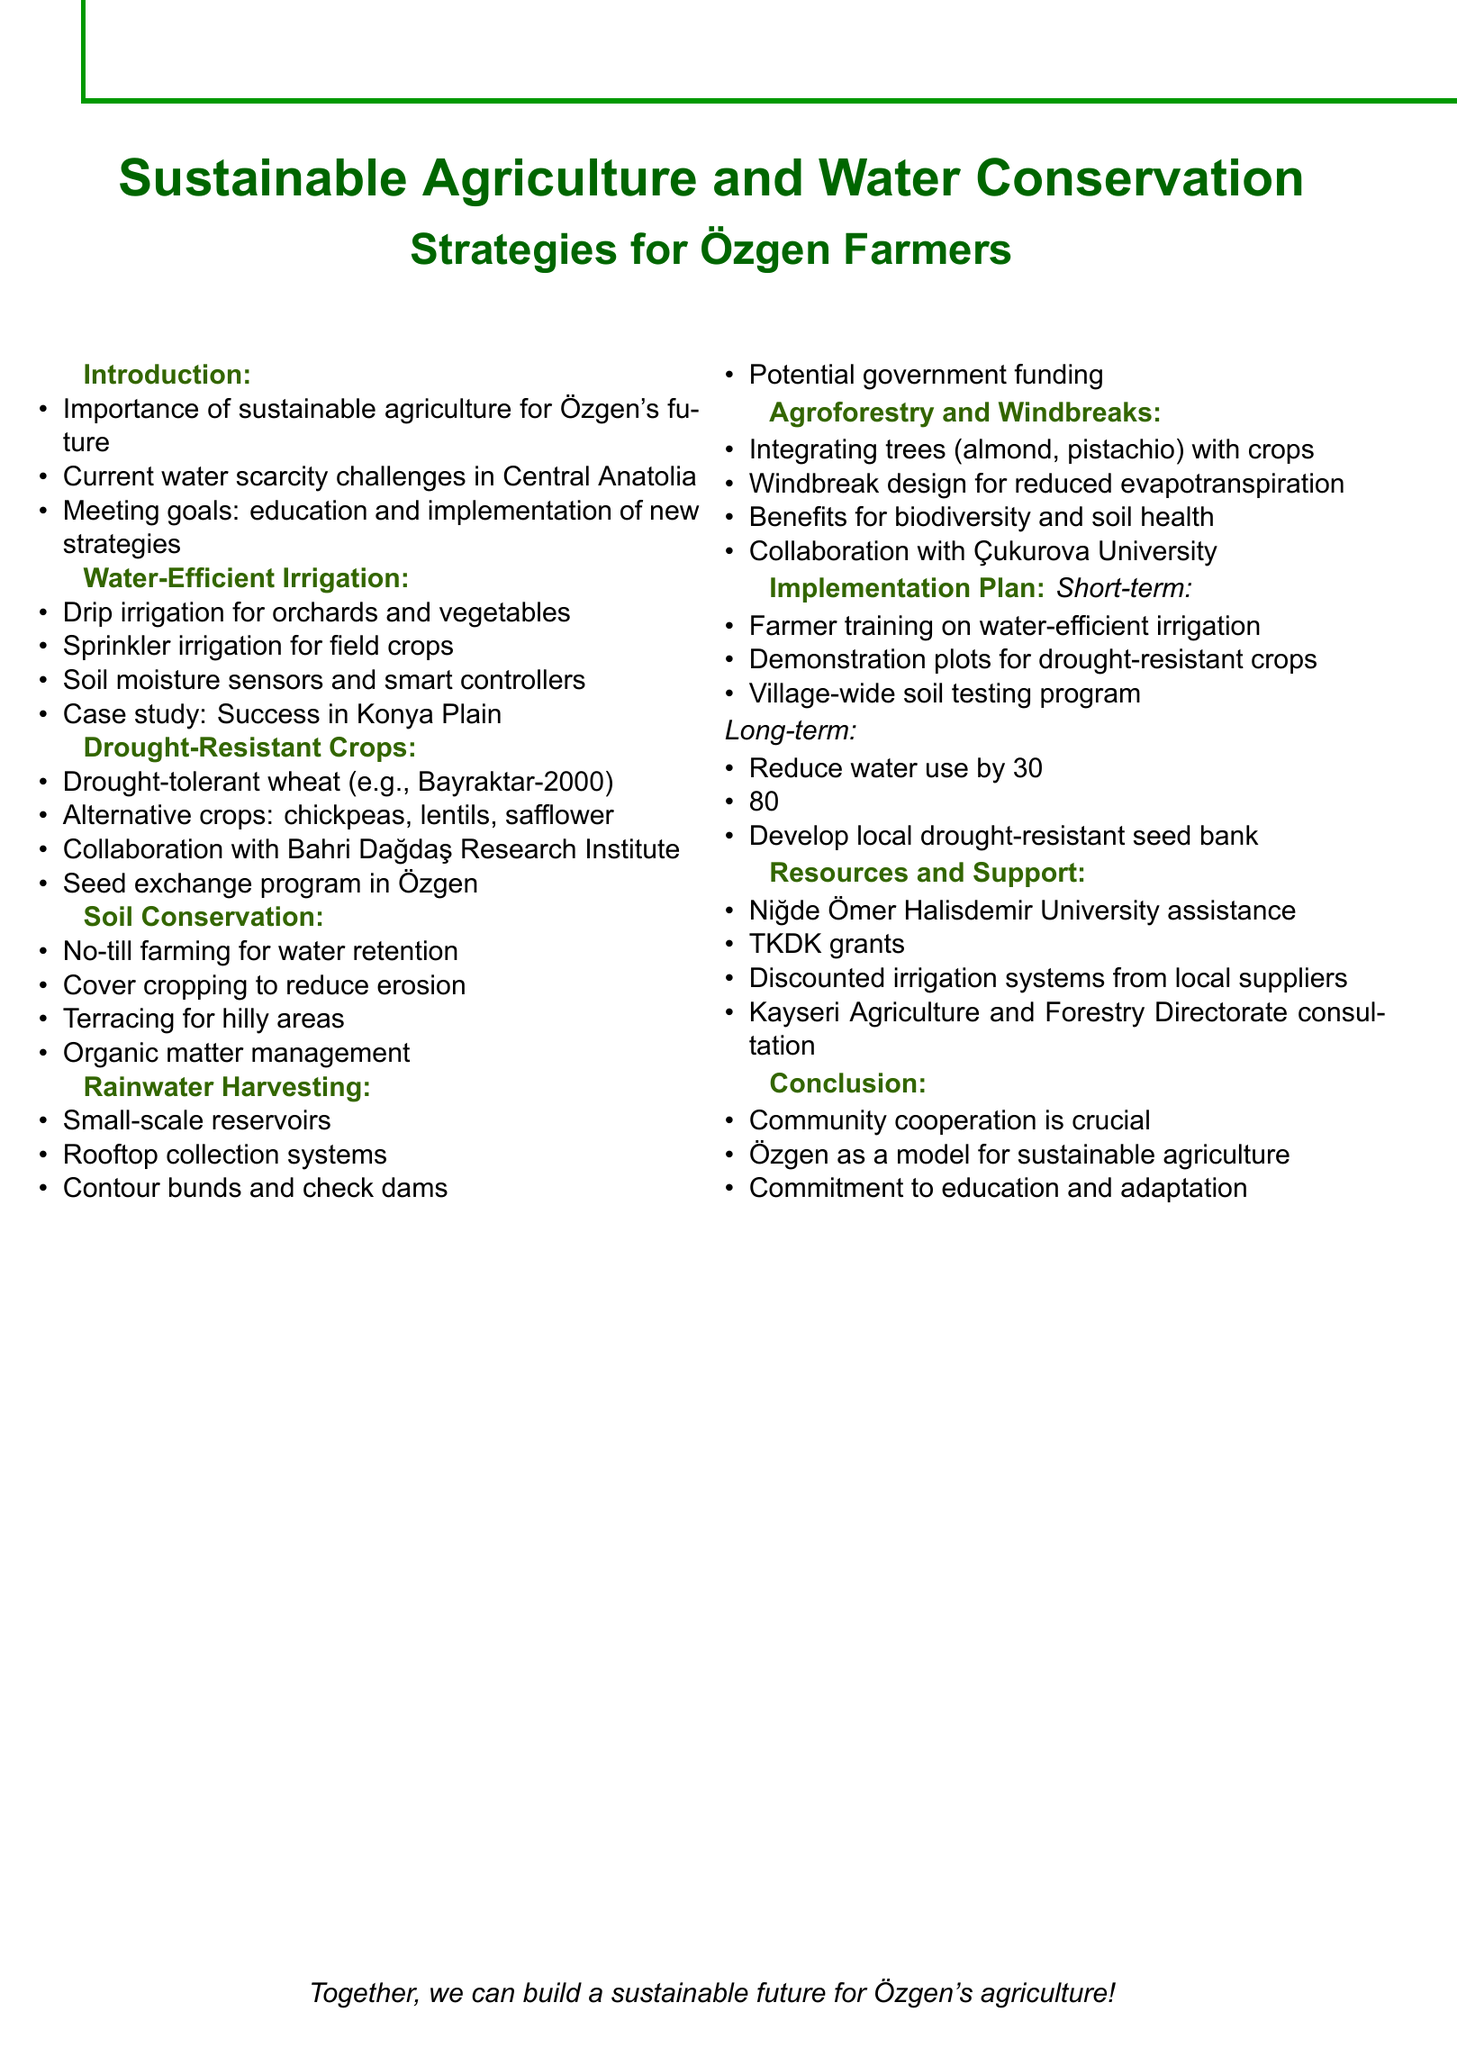What is the title of the agenda? The title is explicitly stated at the beginning of the document.
Answer: Sustainable Agriculture and Water Conservation Strategies for Özgen Farmers What is one water-efficient irrigation technique mentioned? The document lists specific techniques under the relevant section.
Answer: Drip irrigation systems What is the target reduction in water consumption for agriculture in Özgen? The long-term goal outlines specific targets to achieve within a set timeframe.
Answer: 30% Which crop variety is introduced as drought-tolerant? The document provides specific examples of crop varieties that are highlighted.
Answer: Bayraktar-2000 What practice is recommended for soil conservation? The document lists specific practices under the soil conservation topic.
Answer: No-till farming What funding potential is mentioned for rainwater harvesting? The document refers to potential sources of funding relevant to the topic.
Answer: Turkish Ministry of Agriculture and Forestry What percentage of farms is the goal for adopting sustainable practices? The long-term goals section specifies a target percentage for adoption.
Answer: 80% Which institution is mentioned for technical assistance? The document names various institutions that can provide support.
Answer: Niğde Ömer Halisdemir University What type of crops is suggested as alternatives to traditional ones? The document provides specific alternatives in the context of drought-resistant crops.
Answer: Chickpeas, lentils, safflower 